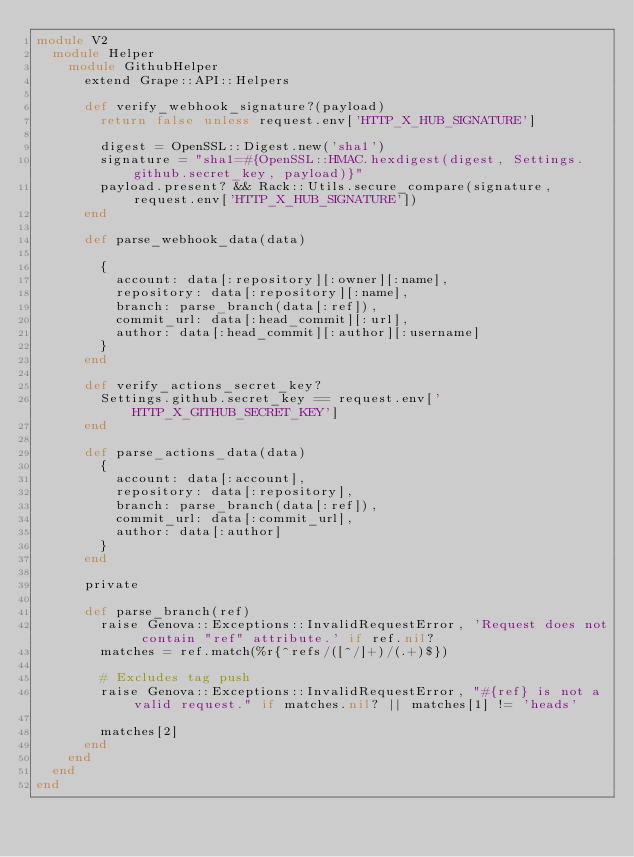<code> <loc_0><loc_0><loc_500><loc_500><_Ruby_>module V2
  module Helper
    module GithubHelper
      extend Grape::API::Helpers

      def verify_webhook_signature?(payload)
        return false unless request.env['HTTP_X_HUB_SIGNATURE']

        digest = OpenSSL::Digest.new('sha1')
        signature = "sha1=#{OpenSSL::HMAC.hexdigest(digest, Settings.github.secret_key, payload)}"
        payload.present? && Rack::Utils.secure_compare(signature, request.env['HTTP_X_HUB_SIGNATURE'])
      end

      def parse_webhook_data(data)

        {
          account: data[:repository][:owner][:name],
          repository: data[:repository][:name],
          branch: parse_branch(data[:ref]),
          commit_url: data[:head_commit][:url],
          author: data[:head_commit][:author][:username]
        }
      end

      def verify_actions_secret_key?
        Settings.github.secret_key == request.env['HTTP_X_GITHUB_SECRET_KEY']
      end

      def parse_actions_data(data)
        {
          account: data[:account],
          repository: data[:repository],
          branch: parse_branch(data[:ref]),
          commit_url: data[:commit_url],
          author: data[:author]
        }
      end

      private

      def parse_branch(ref)
        raise Genova::Exceptions::InvalidRequestError, 'Request does not contain "ref" attribute.' if ref.nil?
        matches = ref.match(%r{^refs/([^/]+)/(.+)$})

        # Excludes tag push
        raise Genova::Exceptions::InvalidRequestError, "#{ref} is not a valid request." if matches.nil? || matches[1] != 'heads'

        matches[2]
      end
    end
  end
end
</code> 